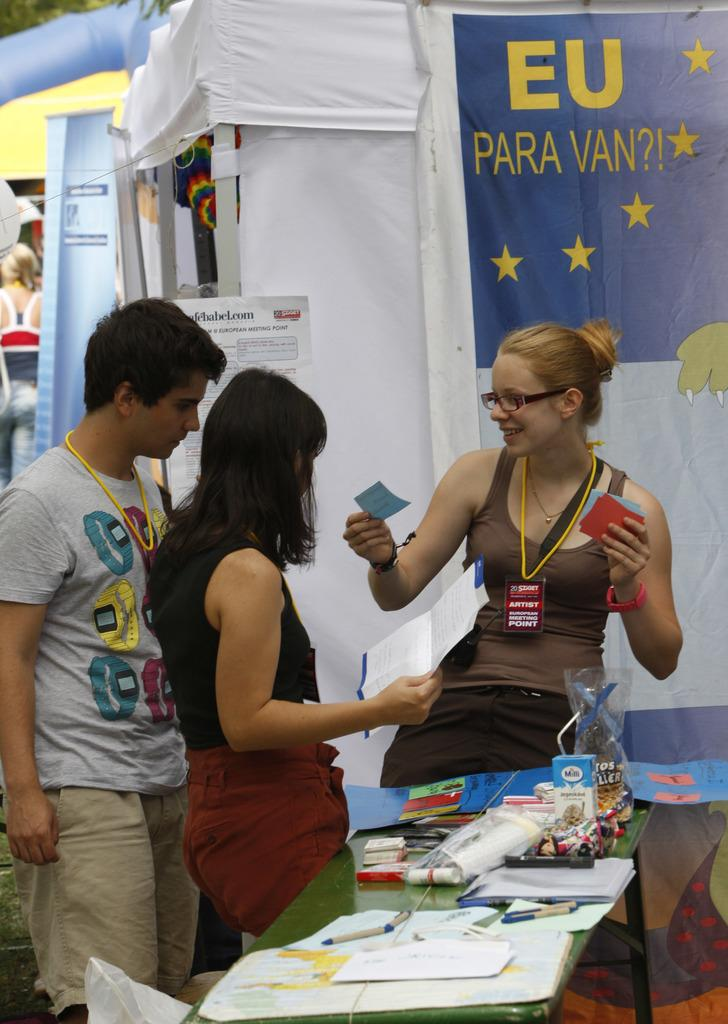Provide a one-sentence caption for the provided image. A group of students hanging out by a EU para van sign. 